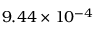Convert formula to latex. <formula><loc_0><loc_0><loc_500><loc_500>9 . 4 4 \times 1 0 ^ { - 4 }</formula> 